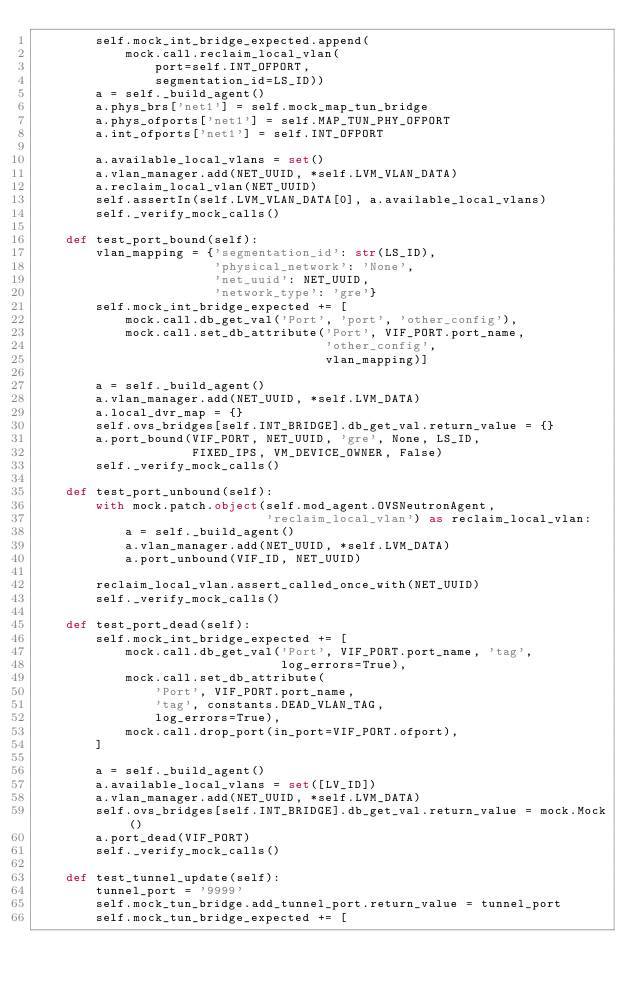<code> <loc_0><loc_0><loc_500><loc_500><_Python_>        self.mock_int_bridge_expected.append(
            mock.call.reclaim_local_vlan(
                port=self.INT_OFPORT,
                segmentation_id=LS_ID))
        a = self._build_agent()
        a.phys_brs['net1'] = self.mock_map_tun_bridge
        a.phys_ofports['net1'] = self.MAP_TUN_PHY_OFPORT
        a.int_ofports['net1'] = self.INT_OFPORT

        a.available_local_vlans = set()
        a.vlan_manager.add(NET_UUID, *self.LVM_VLAN_DATA)
        a.reclaim_local_vlan(NET_UUID)
        self.assertIn(self.LVM_VLAN_DATA[0], a.available_local_vlans)
        self._verify_mock_calls()

    def test_port_bound(self):
        vlan_mapping = {'segmentation_id': str(LS_ID),
                        'physical_network': 'None',
                        'net_uuid': NET_UUID,
                        'network_type': 'gre'}
        self.mock_int_bridge_expected += [
            mock.call.db_get_val('Port', 'port', 'other_config'),
            mock.call.set_db_attribute('Port', VIF_PORT.port_name,
                                       'other_config',
                                       vlan_mapping)]

        a = self._build_agent()
        a.vlan_manager.add(NET_UUID, *self.LVM_DATA)
        a.local_dvr_map = {}
        self.ovs_bridges[self.INT_BRIDGE].db_get_val.return_value = {}
        a.port_bound(VIF_PORT, NET_UUID, 'gre', None, LS_ID,
                     FIXED_IPS, VM_DEVICE_OWNER, False)
        self._verify_mock_calls()

    def test_port_unbound(self):
        with mock.patch.object(self.mod_agent.OVSNeutronAgent,
                               'reclaim_local_vlan') as reclaim_local_vlan:
            a = self._build_agent()
            a.vlan_manager.add(NET_UUID, *self.LVM_DATA)
            a.port_unbound(VIF_ID, NET_UUID)

        reclaim_local_vlan.assert_called_once_with(NET_UUID)
        self._verify_mock_calls()

    def test_port_dead(self):
        self.mock_int_bridge_expected += [
            mock.call.db_get_val('Port', VIF_PORT.port_name, 'tag',
                                 log_errors=True),
            mock.call.set_db_attribute(
                'Port', VIF_PORT.port_name,
                'tag', constants.DEAD_VLAN_TAG,
                log_errors=True),
            mock.call.drop_port(in_port=VIF_PORT.ofport),
        ]

        a = self._build_agent()
        a.available_local_vlans = set([LV_ID])
        a.vlan_manager.add(NET_UUID, *self.LVM_DATA)
        self.ovs_bridges[self.INT_BRIDGE].db_get_val.return_value = mock.Mock()
        a.port_dead(VIF_PORT)
        self._verify_mock_calls()

    def test_tunnel_update(self):
        tunnel_port = '9999'
        self.mock_tun_bridge.add_tunnel_port.return_value = tunnel_port
        self.mock_tun_bridge_expected += [</code> 